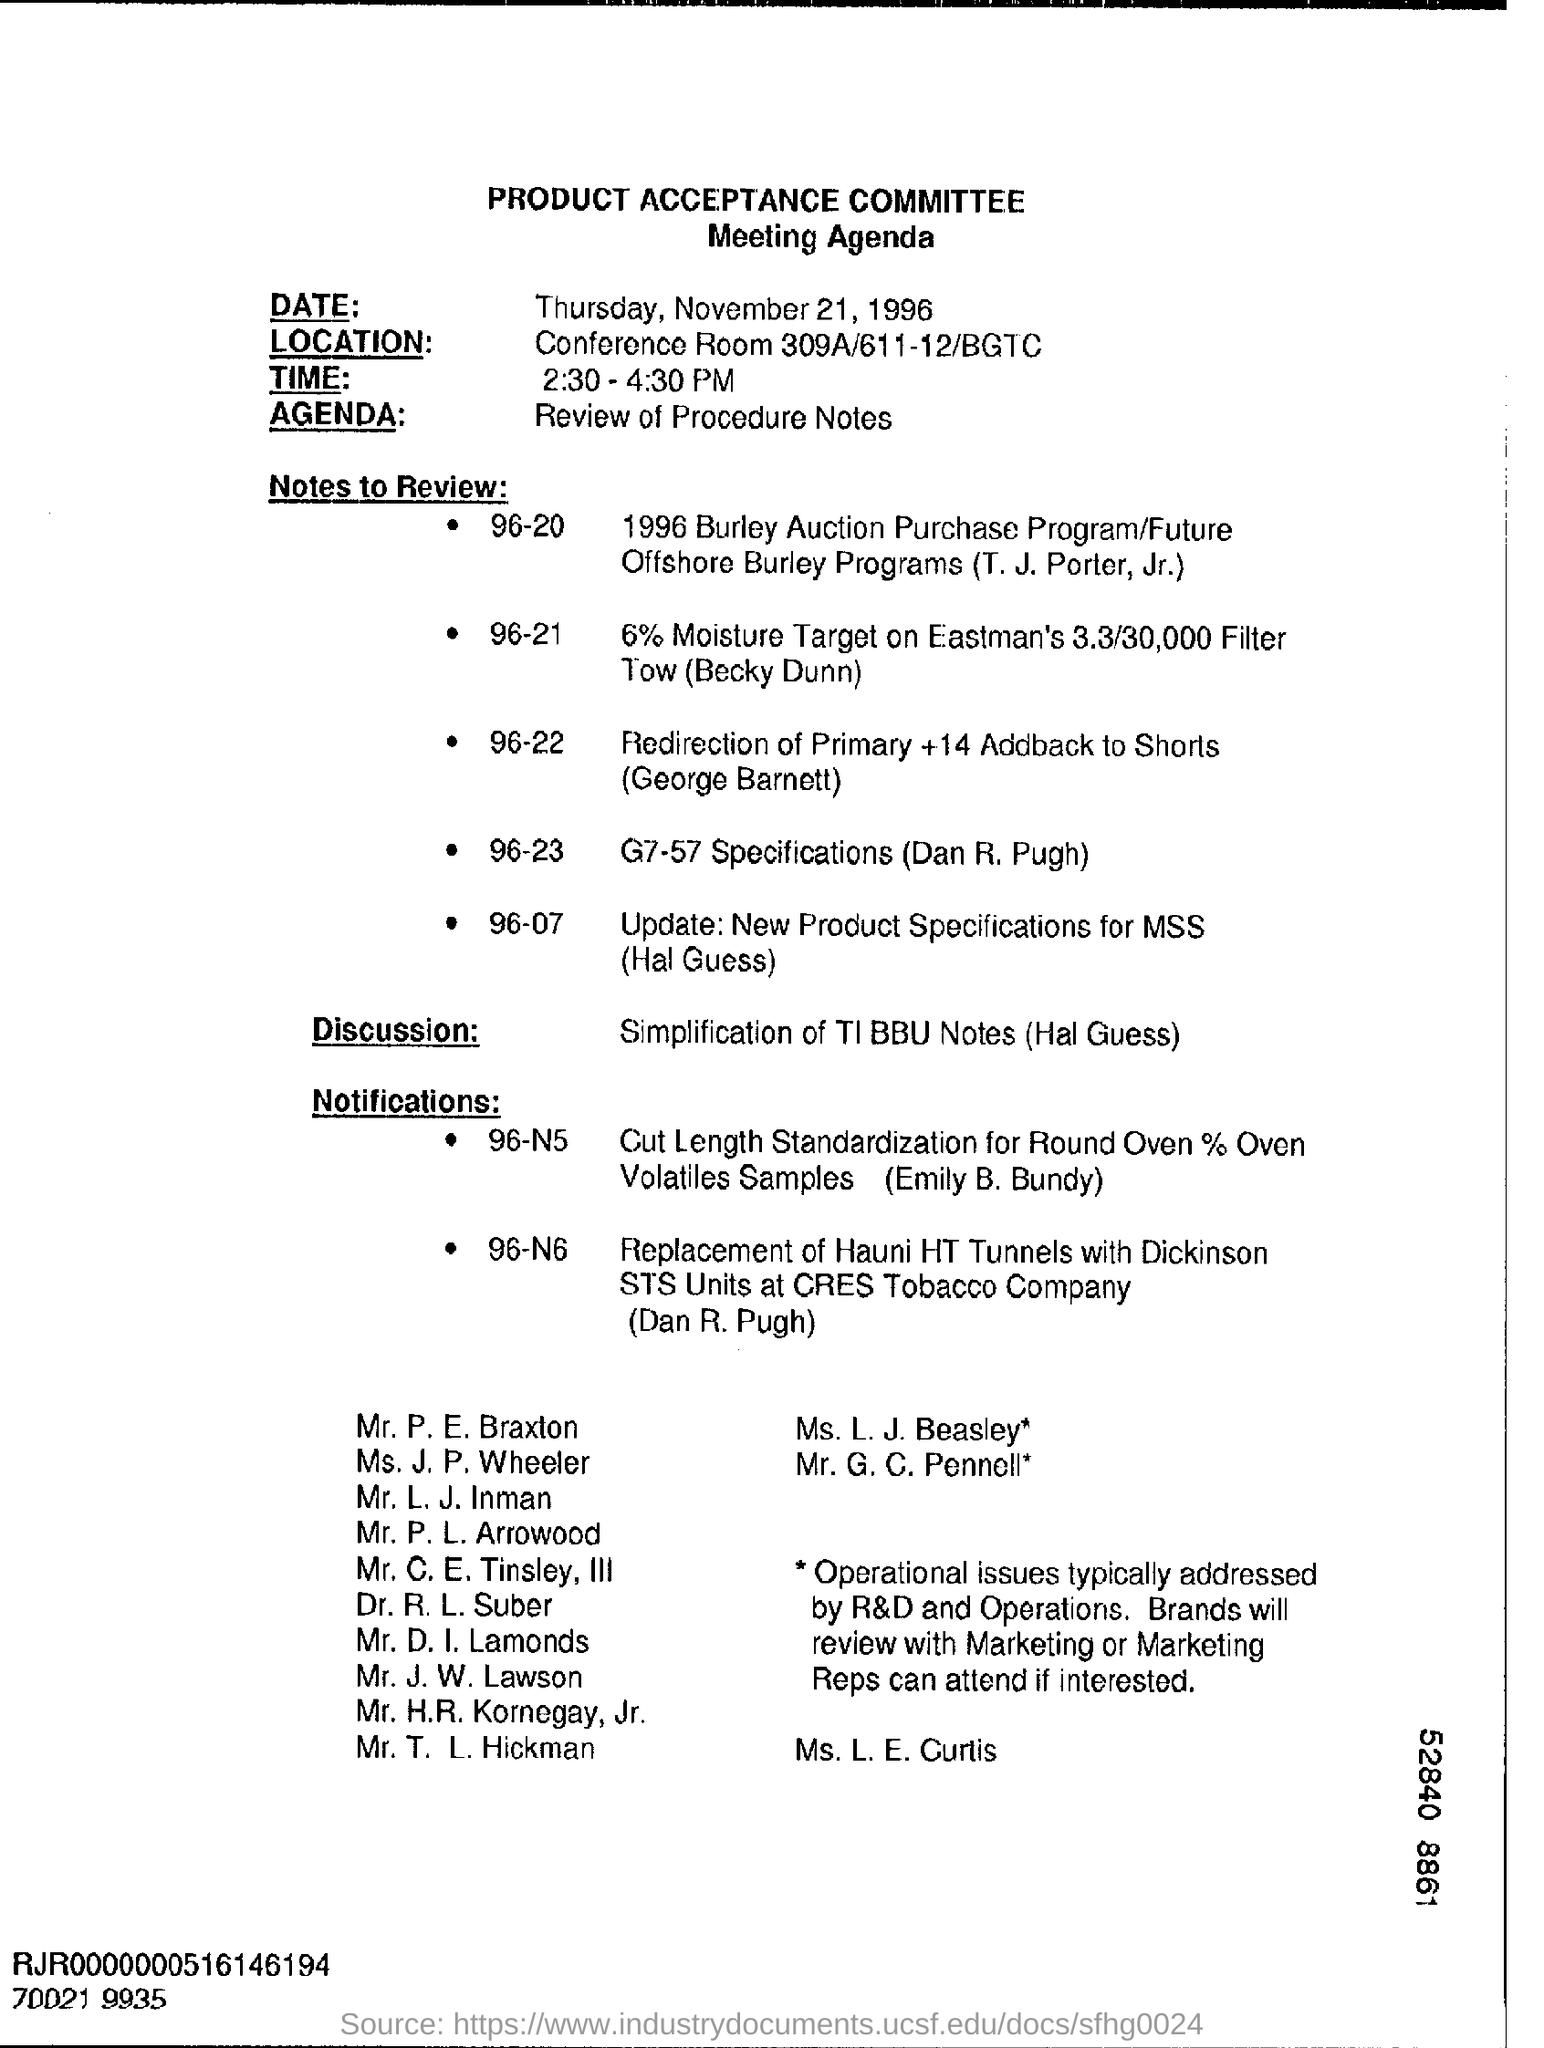What is the date mentioned in the top of the document ?
Provide a succinct answer. Thursday, November 21, 1996. Where is the Location ?
Your answer should be compact. Conference Room 309A/611-12/BGTC. What is written in the Agenda Field ?
Your answer should be very brief. Review of Procedure Notes. What is the timing of the meeting?
Make the answer very short. 2:30 - 4:30 PM. 